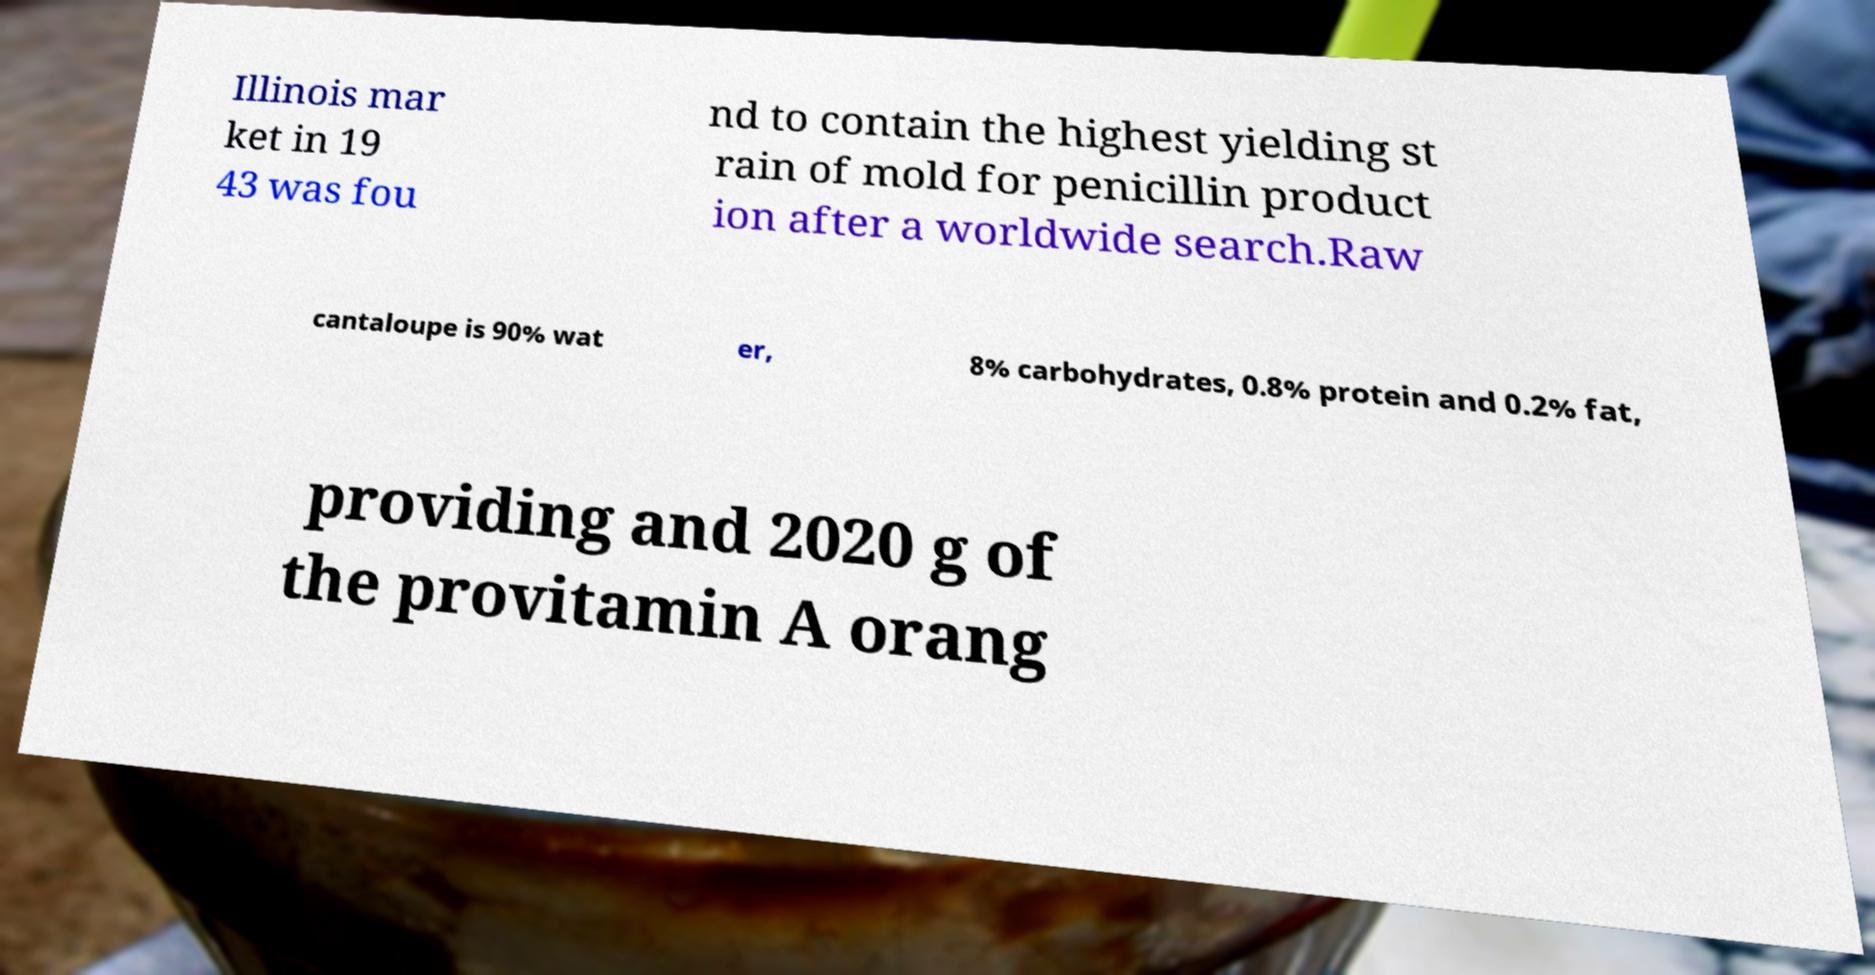Can you read and provide the text displayed in the image?This photo seems to have some interesting text. Can you extract and type it out for me? Illinois mar ket in 19 43 was fou nd to contain the highest yielding st rain of mold for penicillin product ion after a worldwide search.Raw cantaloupe is 90% wat er, 8% carbohydrates, 0.8% protein and 0.2% fat, providing and 2020 g of the provitamin A orang 